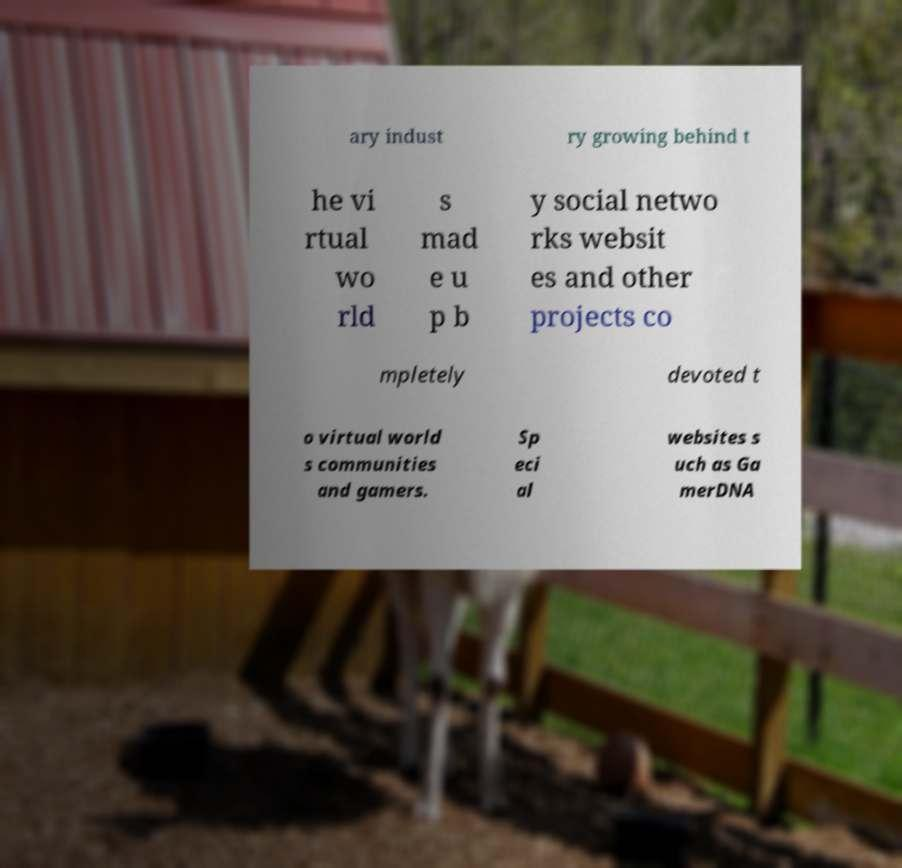Can you read and provide the text displayed in the image?This photo seems to have some interesting text. Can you extract and type it out for me? ary indust ry growing behind t he vi rtual wo rld s mad e u p b y social netwo rks websit es and other projects co mpletely devoted t o virtual world s communities and gamers. Sp eci al websites s uch as Ga merDNA 